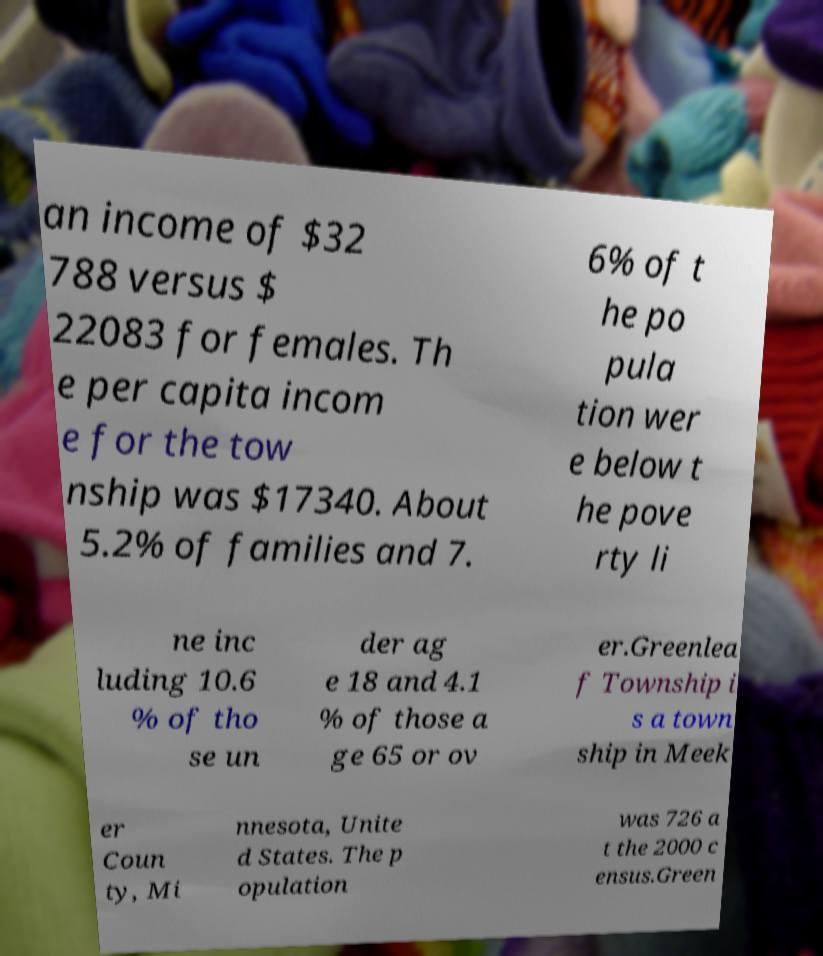Can you accurately transcribe the text from the provided image for me? an income of $32 788 versus $ 22083 for females. Th e per capita incom e for the tow nship was $17340. About 5.2% of families and 7. 6% of t he po pula tion wer e below t he pove rty li ne inc luding 10.6 % of tho se un der ag e 18 and 4.1 % of those a ge 65 or ov er.Greenlea f Township i s a town ship in Meek er Coun ty, Mi nnesota, Unite d States. The p opulation was 726 a t the 2000 c ensus.Green 